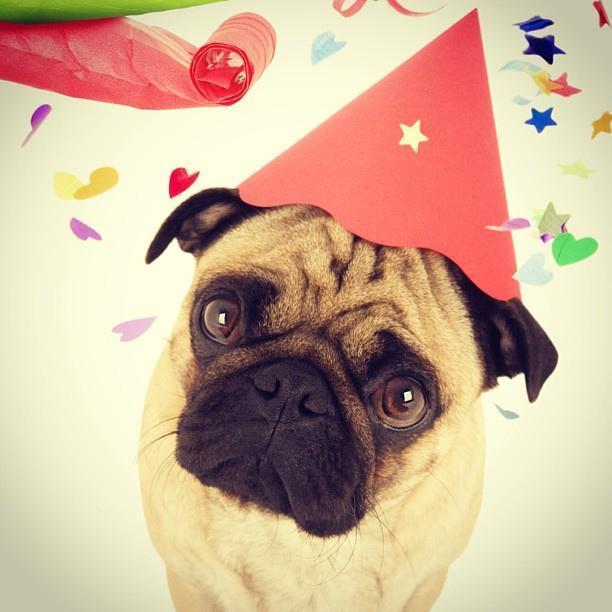How many dogs can you see?
Give a very brief answer. 1. 